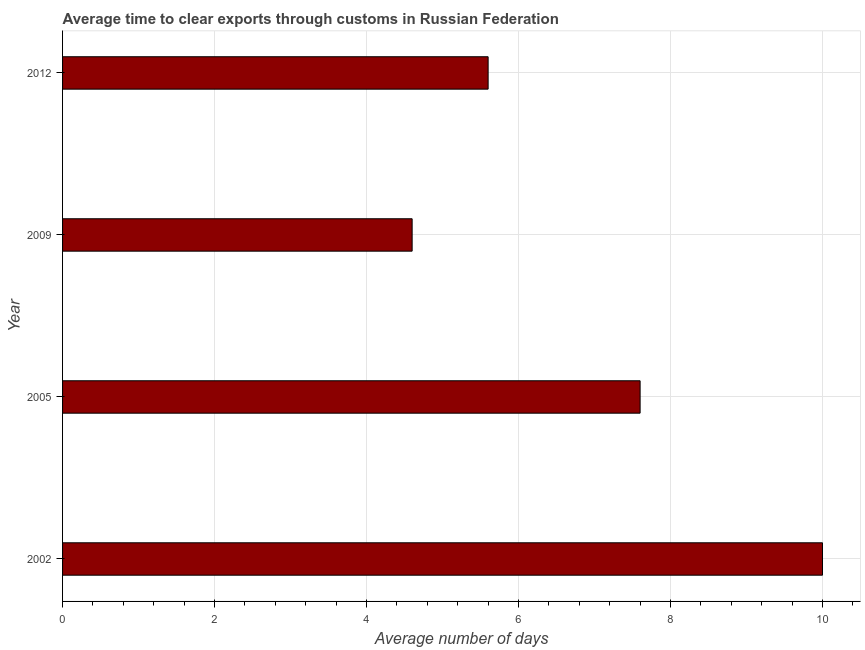What is the title of the graph?
Your answer should be compact. Average time to clear exports through customs in Russian Federation. What is the label or title of the X-axis?
Your answer should be compact. Average number of days. Across all years, what is the maximum time to clear exports through customs?
Your response must be concise. 10. Across all years, what is the minimum time to clear exports through customs?
Your answer should be compact. 4.6. In which year was the time to clear exports through customs minimum?
Provide a short and direct response. 2009. What is the sum of the time to clear exports through customs?
Keep it short and to the point. 27.8. What is the average time to clear exports through customs per year?
Make the answer very short. 6.95. What is the median time to clear exports through customs?
Provide a succinct answer. 6.6. What is the ratio of the time to clear exports through customs in 2002 to that in 2005?
Keep it short and to the point. 1.32. Is the sum of the time to clear exports through customs in 2002 and 2012 greater than the maximum time to clear exports through customs across all years?
Your response must be concise. Yes. In how many years, is the time to clear exports through customs greater than the average time to clear exports through customs taken over all years?
Give a very brief answer. 2. How many bars are there?
Offer a terse response. 4. Are all the bars in the graph horizontal?
Give a very brief answer. Yes. How many years are there in the graph?
Provide a succinct answer. 4. What is the difference between two consecutive major ticks on the X-axis?
Ensure brevity in your answer.  2. Are the values on the major ticks of X-axis written in scientific E-notation?
Your answer should be very brief. No. What is the Average number of days of 2012?
Keep it short and to the point. 5.6. What is the difference between the Average number of days in 2002 and 2005?
Your answer should be compact. 2.4. What is the difference between the Average number of days in 2002 and 2009?
Ensure brevity in your answer.  5.4. What is the difference between the Average number of days in 2005 and 2012?
Provide a short and direct response. 2. What is the difference between the Average number of days in 2009 and 2012?
Provide a succinct answer. -1. What is the ratio of the Average number of days in 2002 to that in 2005?
Make the answer very short. 1.32. What is the ratio of the Average number of days in 2002 to that in 2009?
Provide a short and direct response. 2.17. What is the ratio of the Average number of days in 2002 to that in 2012?
Your response must be concise. 1.79. What is the ratio of the Average number of days in 2005 to that in 2009?
Provide a succinct answer. 1.65. What is the ratio of the Average number of days in 2005 to that in 2012?
Ensure brevity in your answer.  1.36. What is the ratio of the Average number of days in 2009 to that in 2012?
Offer a terse response. 0.82. 